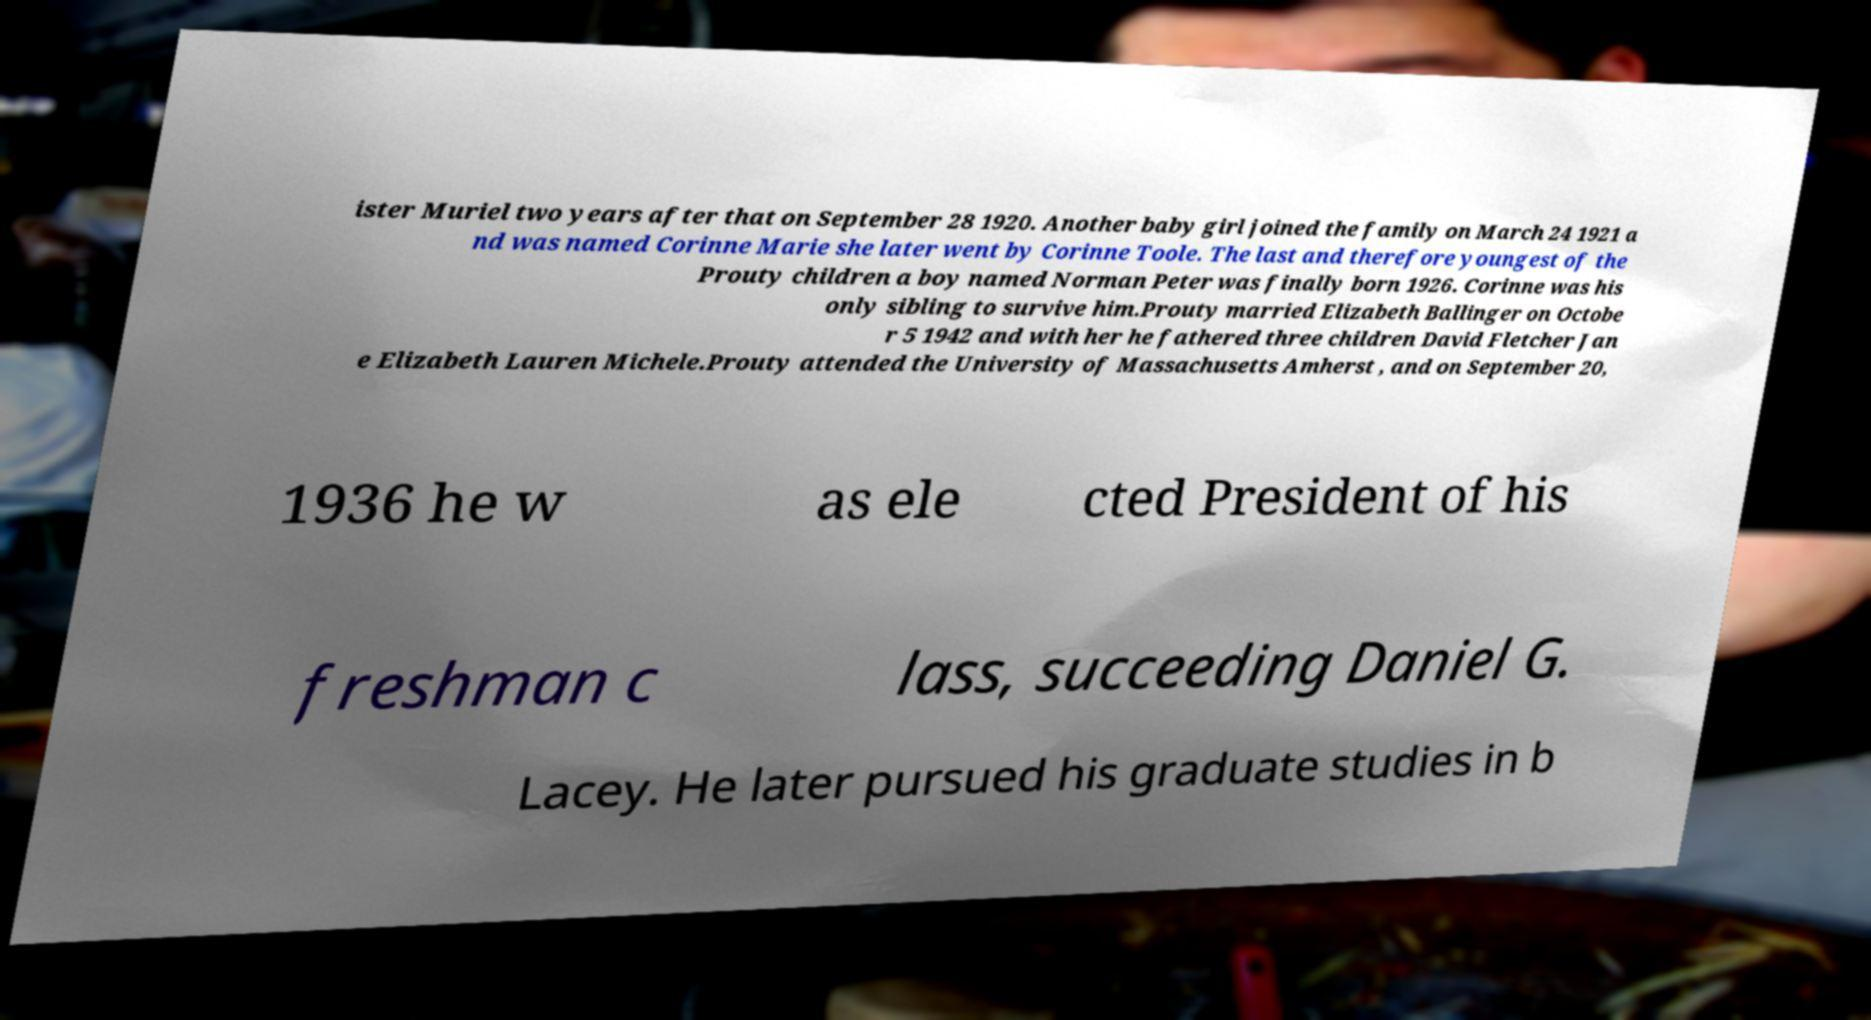Please identify and transcribe the text found in this image. ister Muriel two years after that on September 28 1920. Another baby girl joined the family on March 24 1921 a nd was named Corinne Marie she later went by Corinne Toole. The last and therefore youngest of the Prouty children a boy named Norman Peter was finally born 1926. Corinne was his only sibling to survive him.Prouty married Elizabeth Ballinger on Octobe r 5 1942 and with her he fathered three children David Fletcher Jan e Elizabeth Lauren Michele.Prouty attended the University of Massachusetts Amherst , and on September 20, 1936 he w as ele cted President of his freshman c lass, succeeding Daniel G. Lacey. He later pursued his graduate studies in b 